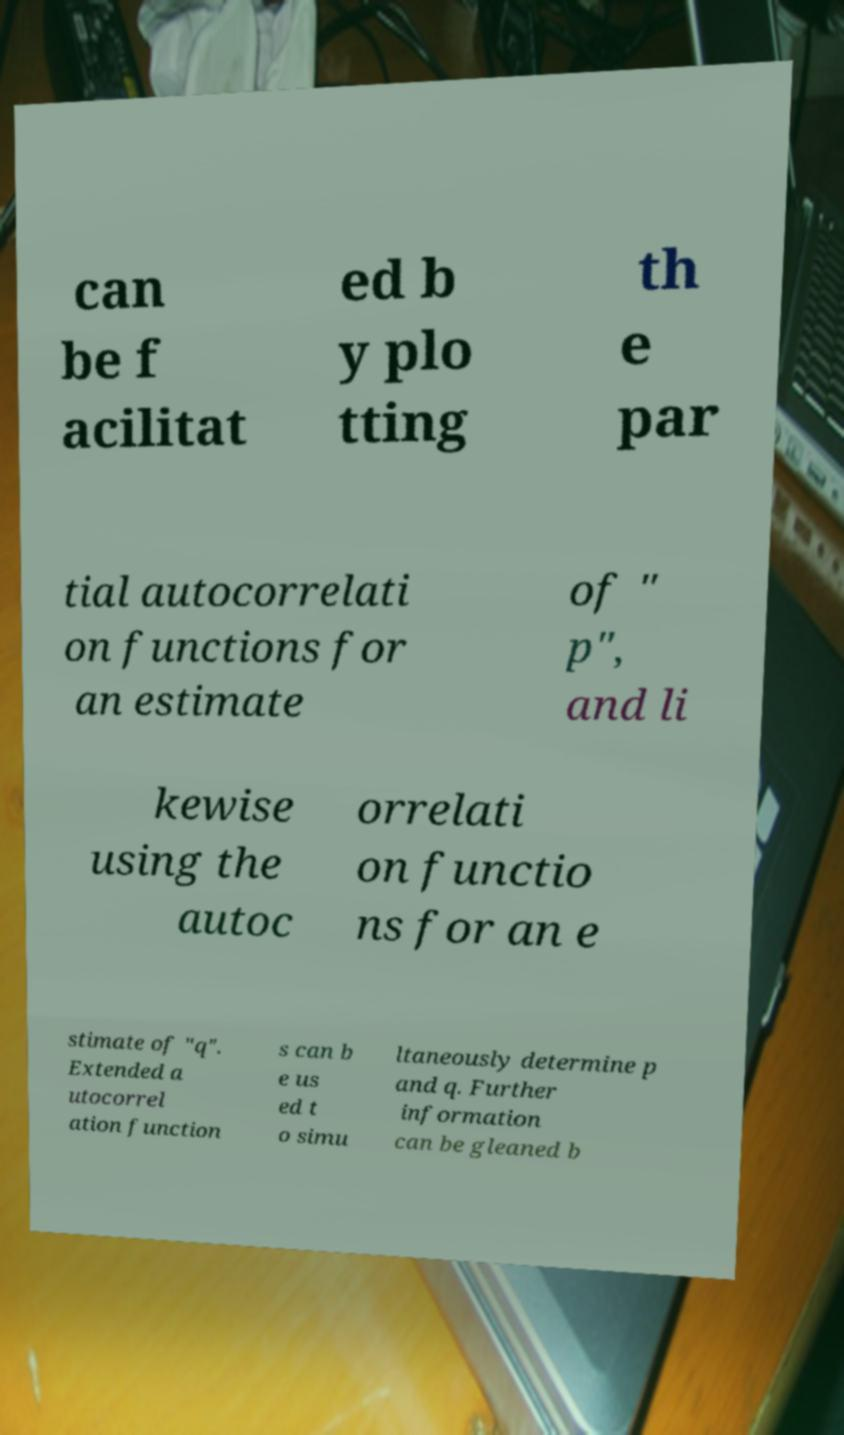I need the written content from this picture converted into text. Can you do that? can be f acilitat ed b y plo tting th e par tial autocorrelati on functions for an estimate of " p", and li kewise using the autoc orrelati on functio ns for an e stimate of "q". Extended a utocorrel ation function s can b e us ed t o simu ltaneously determine p and q. Further information can be gleaned b 